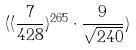Convert formula to latex. <formula><loc_0><loc_0><loc_500><loc_500>( ( \frac { 7 } { 4 2 8 } ) ^ { 2 6 5 } \cdot \frac { 9 } { \sqrt { 2 4 0 } } )</formula> 